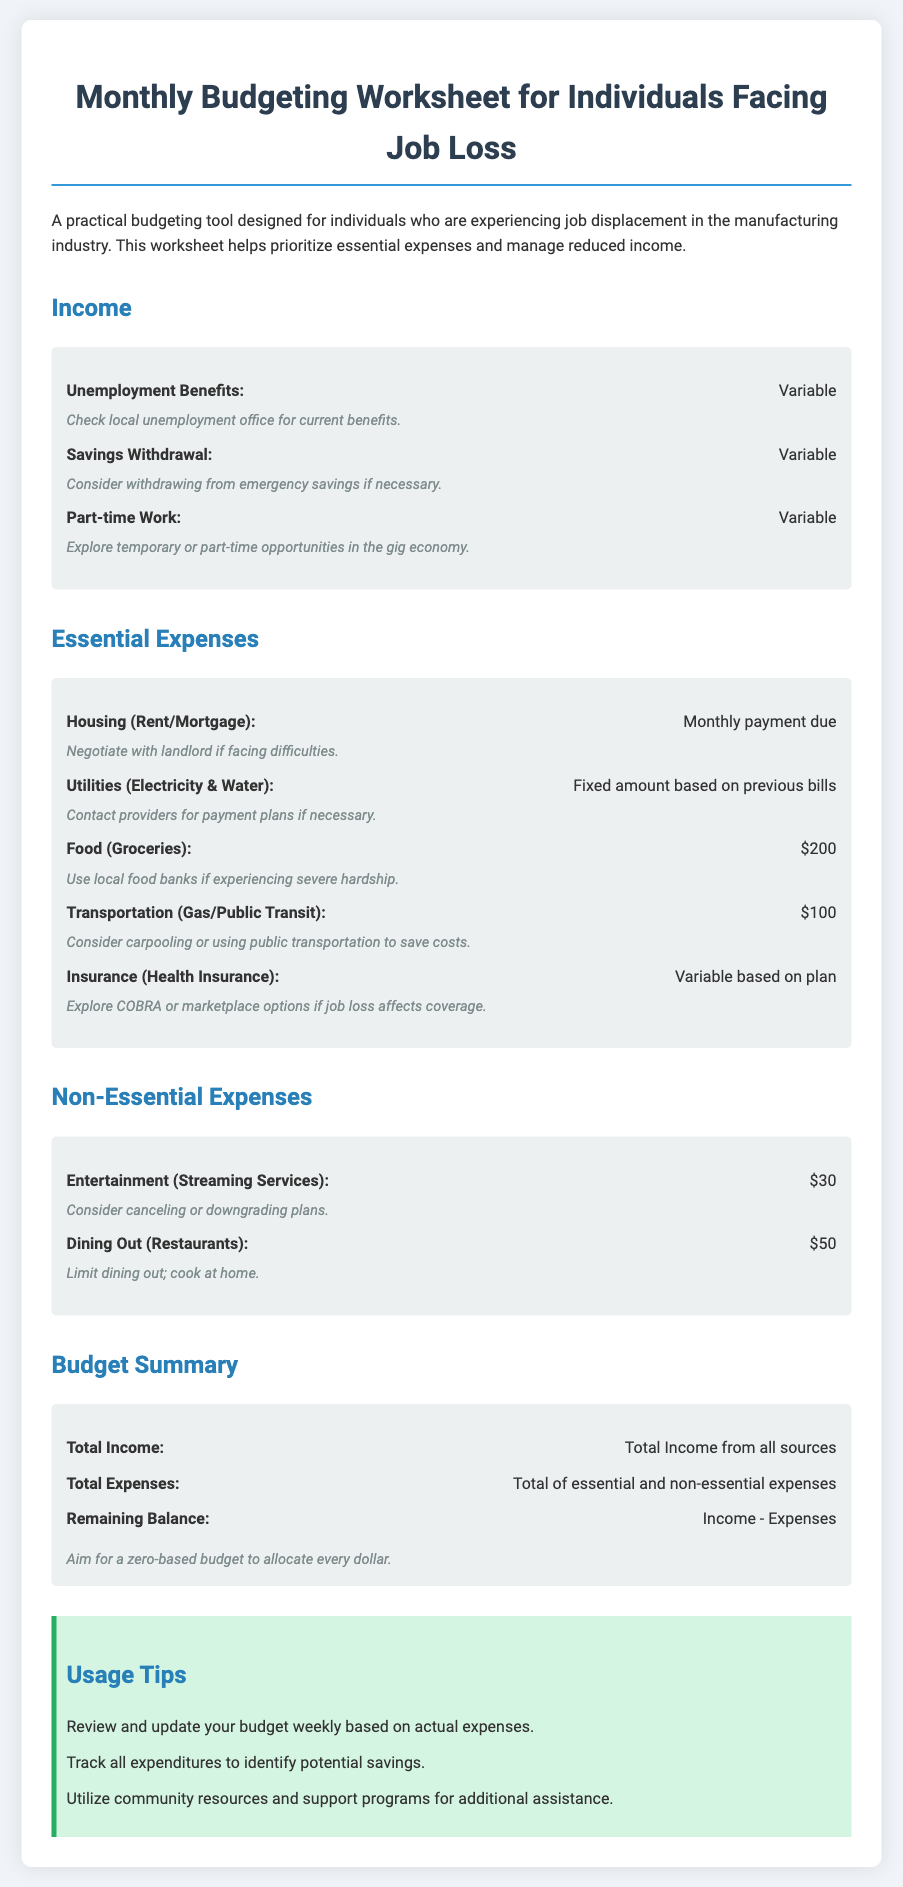What are the categories for income listed in the document? The document lists three categories for income: Unemployment Benefits, Savings Withdrawal, and Part-time Work.
Answer: Unemployment Benefits, Savings Withdrawal, Part-time Work What is the fixed amount listed for Food (Groceries)? The document specifies a fixed amount for Food (Groceries) as $200.
Answer: $200 What should individuals consider doing if they face difficulties with their Housing payment? The document suggests negotiating with the landlord if facing difficulties.
Answer: Negotiate with landlord What is the monthly expense for Transportation? The document states the monthly expense for Transportation is $100.
Answer: $100 What is the recommended action for individuals experiencing severe hardship regarding food? The document advises using local food banks if experiencing severe hardship.
Answer: Use local food banks How should individuals track their budget according to the tips provided? The document suggests reviewing and updating the budget weekly based on actual expenses.
Answer: Weekly updates What type of expenses does the budgeting worksheet prioritize? The document emphasizes prioritizing essential expenses and managing reduced income.
Answer: Essential expenses What is the goal for the Remaining Balance in a zero-based budget? The goal is to allocate every dollar in a zero-based budget, aiming for a zero Remaining Balance.
Answer: Zero Remaining Balance 